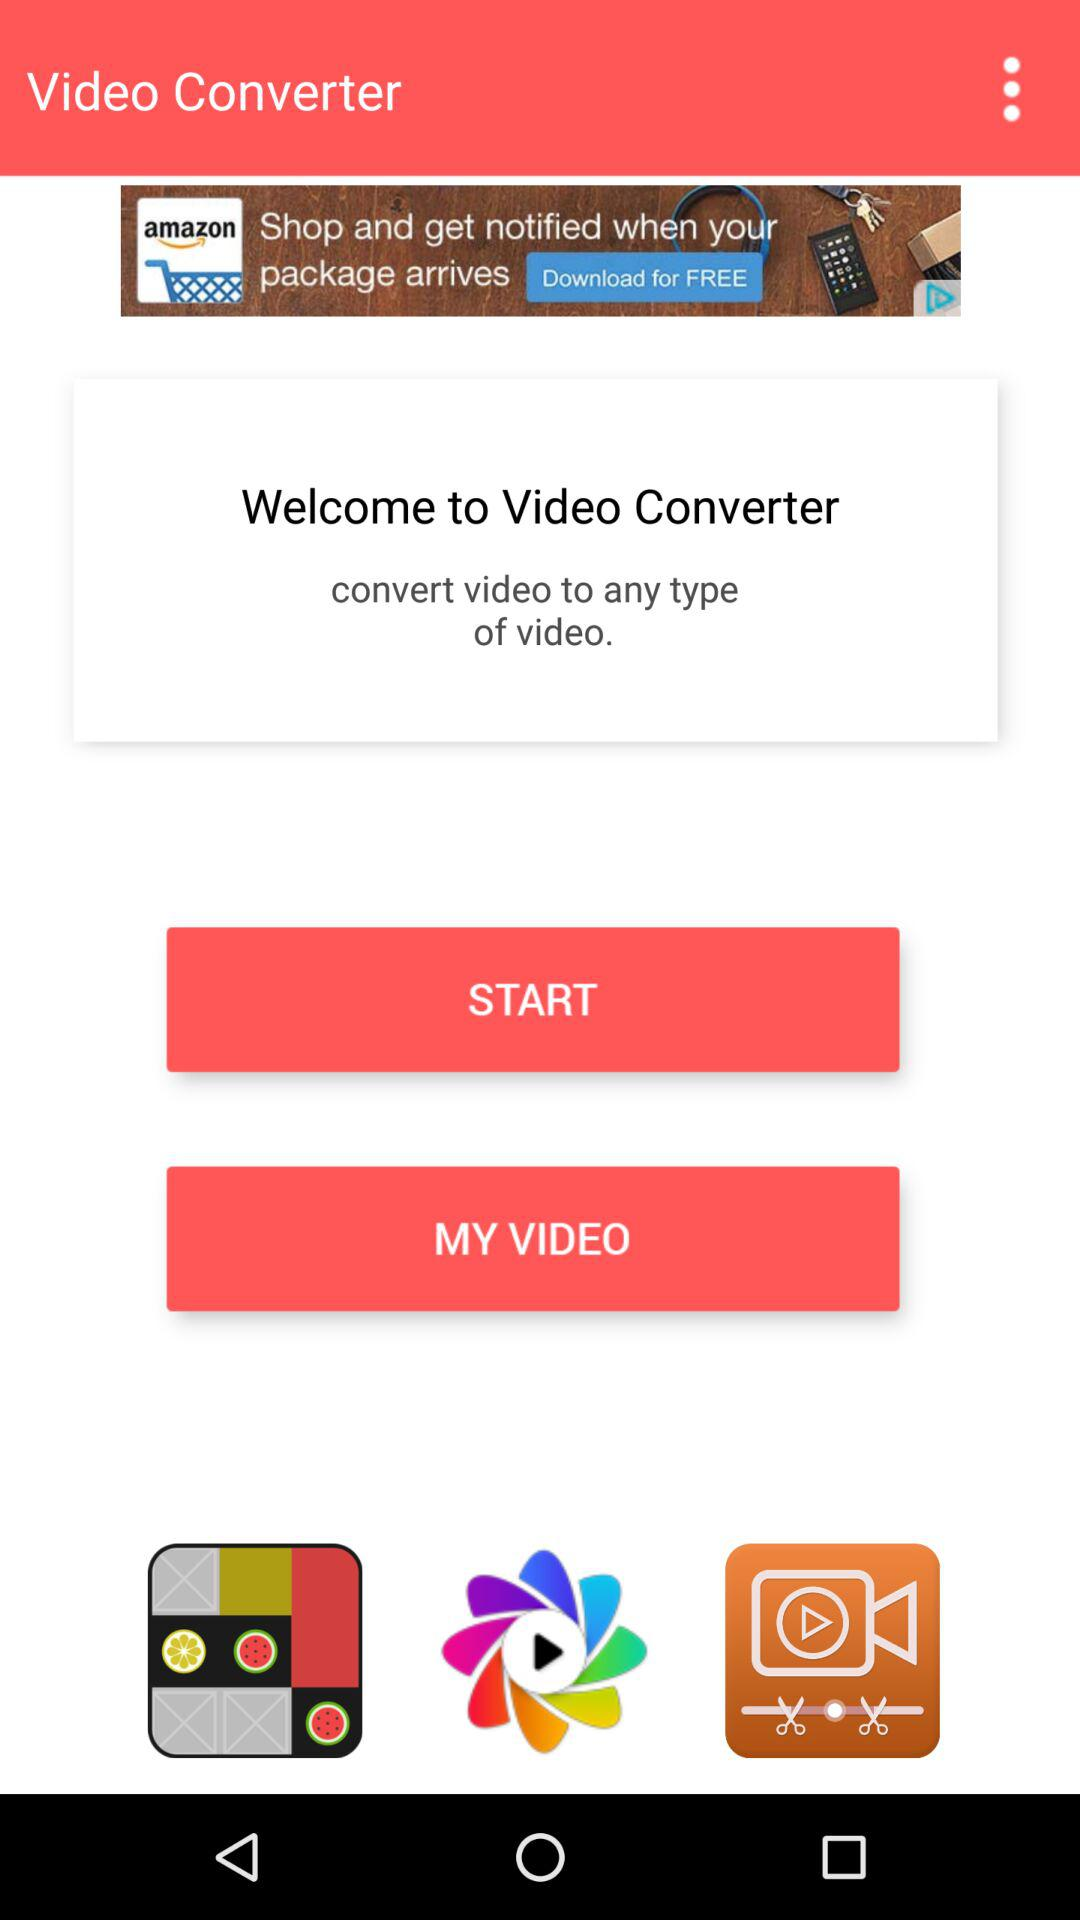What is the name of the application? The name of the application is "Video Converter". 